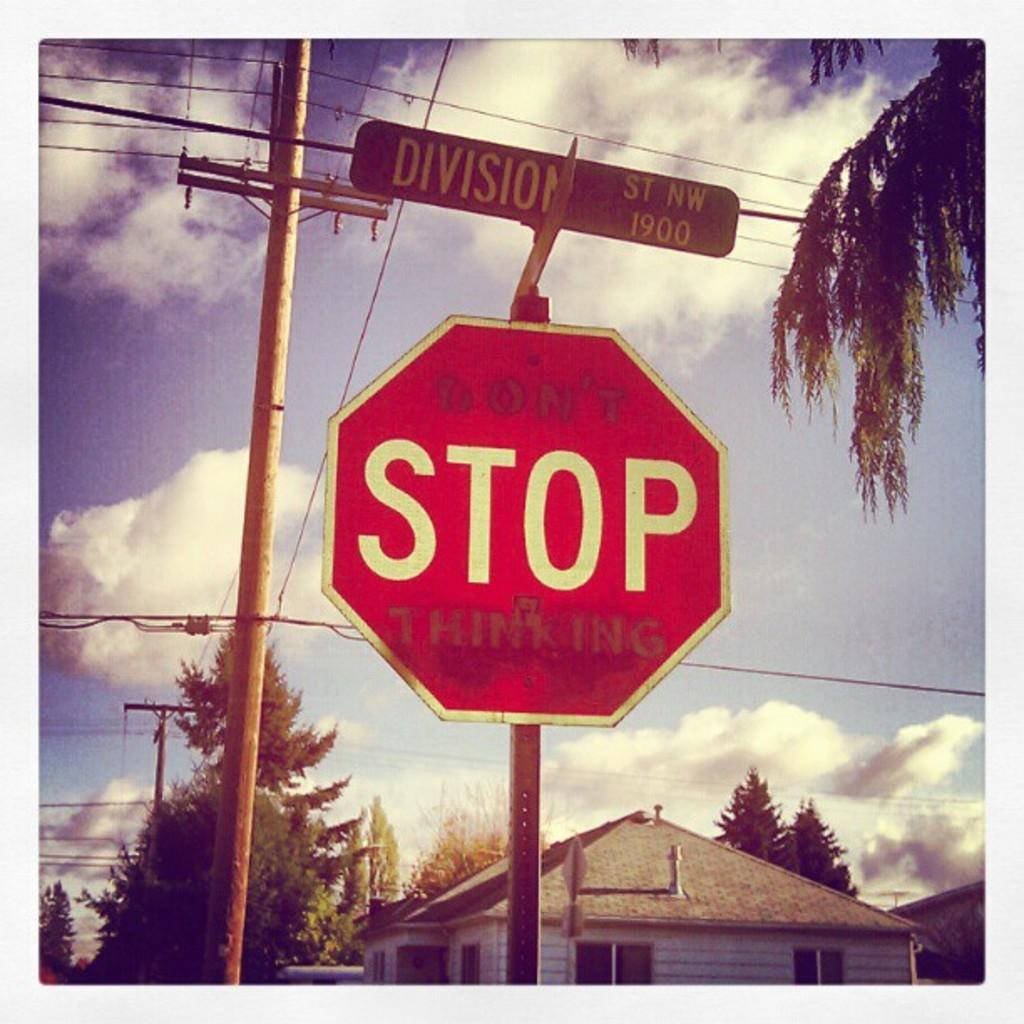<image>
Offer a succinct explanation of the picture presented. A red stop sign has a street sign above it that says Division St NW 1900. 